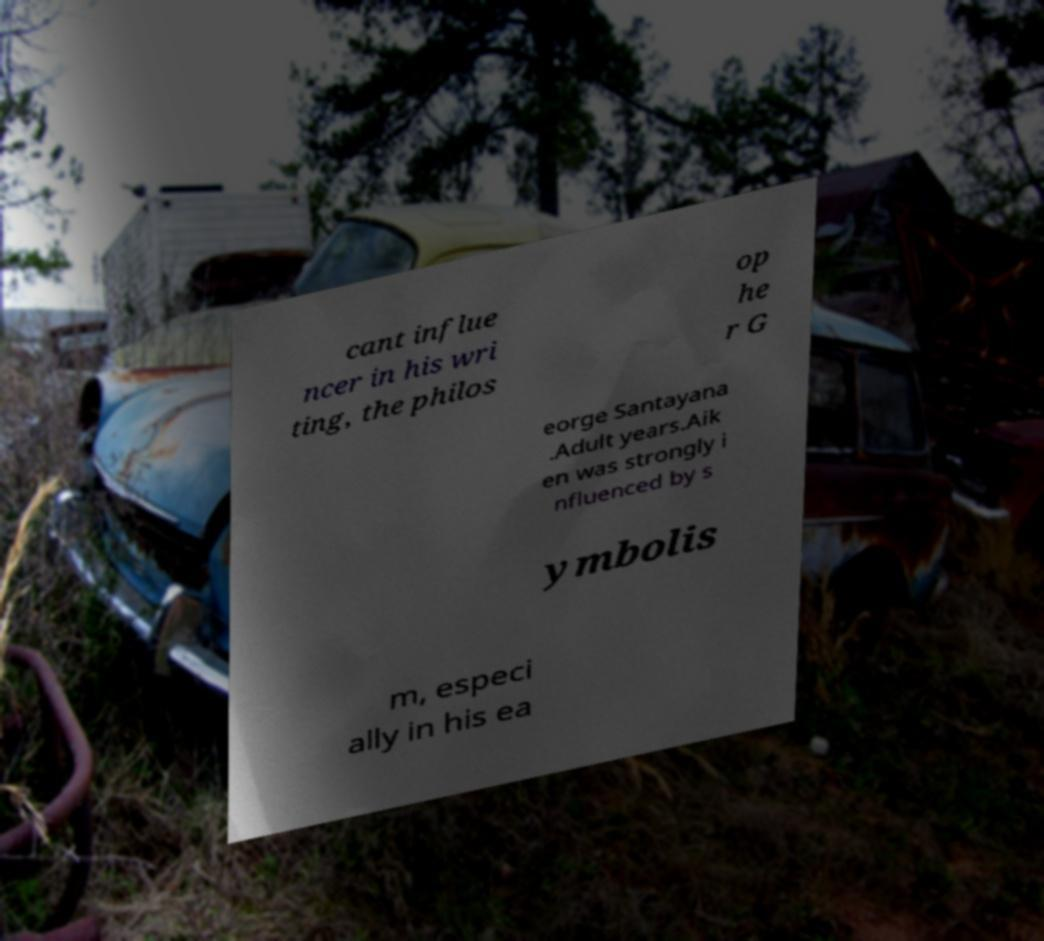Could you assist in decoding the text presented in this image and type it out clearly? cant influe ncer in his wri ting, the philos op he r G eorge Santayana .Adult years.Aik en was strongly i nfluenced by s ymbolis m, especi ally in his ea 